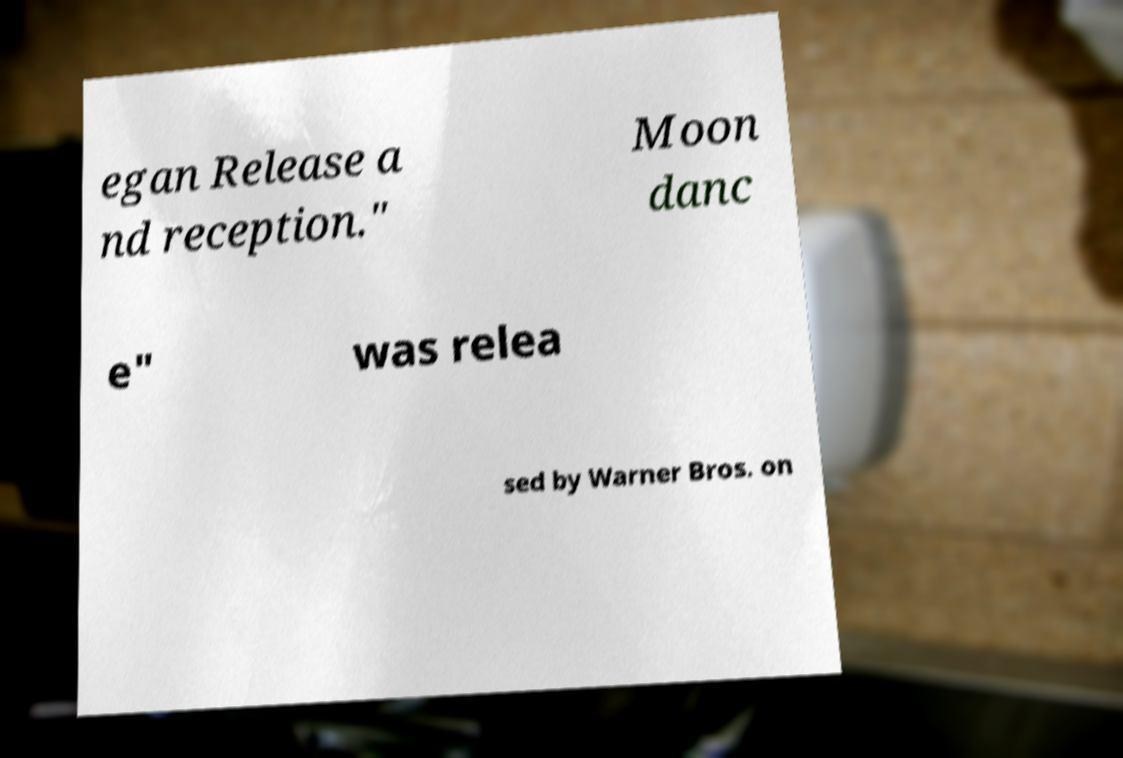What messages or text are displayed in this image? I need them in a readable, typed format. egan Release a nd reception." Moon danc e" was relea sed by Warner Bros. on 